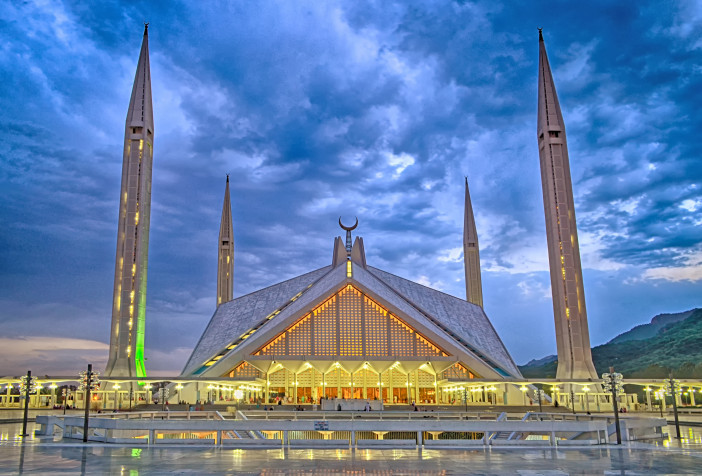Can you explain the significance of the design of the Faisal Mosque? The design of the Faisal Mosque is significant as it breaks away from the traditional dome structure common in Islamic architecture. Its triangular prayer hall and four towering minarets were influenced by the shape of a Bedouin tent, symbolizing simplicity and strength. This architectural choice not only gives the mosque its distinctive appearance but also represents a blend of modernist ethos with Islamic traditions, embodying the progressiveness of Pakistan. 